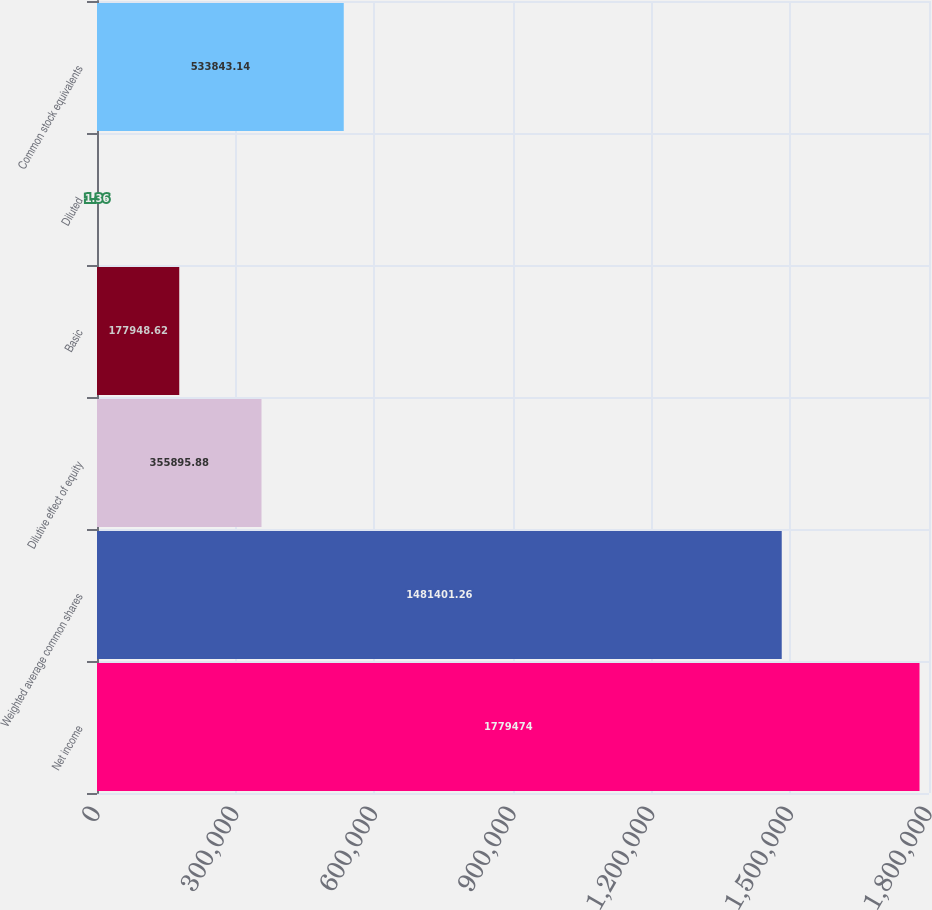Convert chart to OTSL. <chart><loc_0><loc_0><loc_500><loc_500><bar_chart><fcel>Net income<fcel>Weighted average common shares<fcel>Dilutive effect of equity<fcel>Basic<fcel>Diluted<fcel>Common stock equivalents<nl><fcel>1.77947e+06<fcel>1.4814e+06<fcel>355896<fcel>177949<fcel>1.36<fcel>533843<nl></chart> 